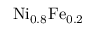<formula> <loc_0><loc_0><loc_500><loc_500>N i _ { 0 . 8 } F e _ { 0 . 2 }</formula> 